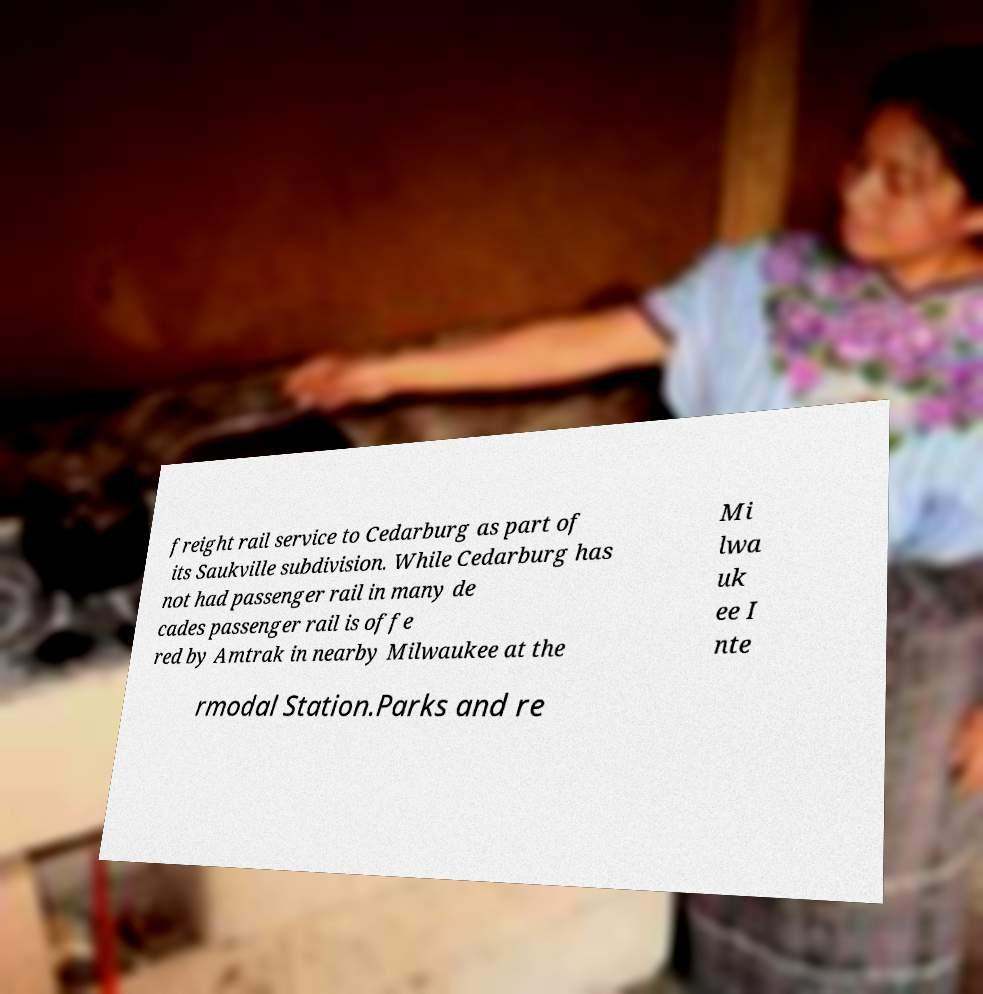There's text embedded in this image that I need extracted. Can you transcribe it verbatim? freight rail service to Cedarburg as part of its Saukville subdivision. While Cedarburg has not had passenger rail in many de cades passenger rail is offe red by Amtrak in nearby Milwaukee at the Mi lwa uk ee I nte rmodal Station.Parks and re 